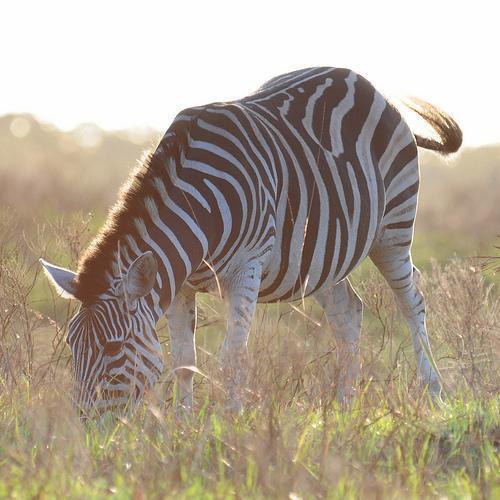How many animals are there?
Give a very brief answer. 1. 